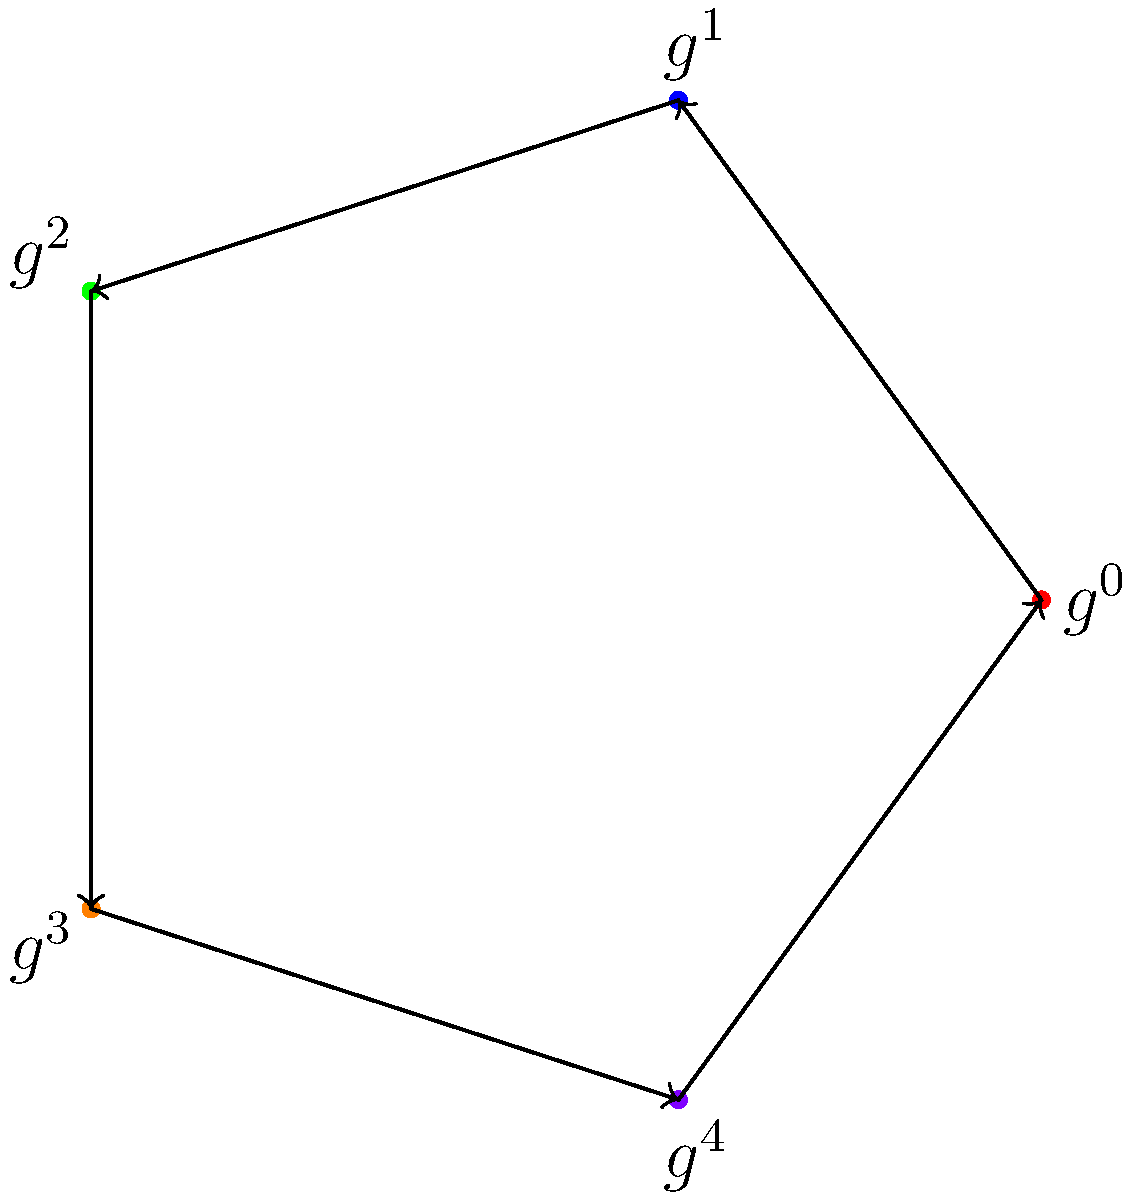In the context of a cryptocurrency's blockchain, consider the cyclic group structure represented by the diagram. If $g$ represents a generator of the group (e.g., a specific block hash), and each subsequent element represents the next block in the chain, what is the order of this group, and what does $g^3 \cdot g^4$ equal in terms of $g$? To solve this problem, let's follow these steps:

1. Identify the order of the group:
   - The diagram shows 5 distinct elements: $g^0, g^1, g^2, g^3, g^4$
   - These elements form a complete cycle
   - Therefore, the order of the group is 5

2. Understand the cyclic nature:
   - In a cyclic group of order 5, $g^5 = g^0 = e$ (the identity element)
   - Any exponent can be reduced modulo 5

3. Calculate $g^3 \cdot g^4$:
   - $g^3 \cdot g^4 = g^{3+4} = g^7$
   - $7 \equiv 2 \pmod{5}$ (since $7 = 1 \times 5 + 2$)
   - Therefore, $g^7 = g^2$

In the context of a blockchain, this operation could represent moving forward 7 blocks from a given point, which is equivalent to moving forward 2 blocks due to the cyclic nature of the group structure.
Answer: Order: 5; $g^3 \cdot g^4 = g^2$ 